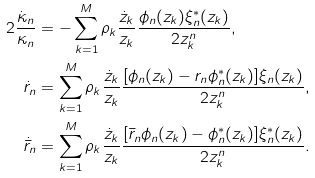<formula> <loc_0><loc_0><loc_500><loc_500>2 \frac { \dot { \kappa } _ { n } } { \kappa _ { n } } & = - \sum ^ { M } _ { k = 1 } \rho _ { k } \frac { \dot { z } _ { k } } { z _ { k } } \frac { \phi _ { n } ( z _ { k } ) \xi ^ { * } _ { n } ( z _ { k } ) } { 2 z _ { k } ^ { n } } , \\ \dot { r } _ { n } & = \sum ^ { M } _ { k = 1 } \rho _ { k } \frac { \dot { z } _ { k } } { z _ { k } } \frac { [ \phi _ { n } ( z _ { k } ) - r _ { n } \phi ^ { * } _ { n } ( z _ { k } ) ] \xi _ { n } ( z _ { k } ) } { 2 z _ { k } ^ { n } } , \\ \dot { \bar { r } } _ { n } & = \sum ^ { M } _ { k = 1 } \rho _ { k } \frac { \dot { z } _ { k } } { z _ { k } } \frac { [ \bar { r } _ { n } \phi _ { n } ( z _ { k } ) - \phi ^ { * } _ { n } ( z _ { k } ) ] \xi ^ { * } _ { n } ( z _ { k } ) } { 2 z _ { k } ^ { n } } .</formula> 